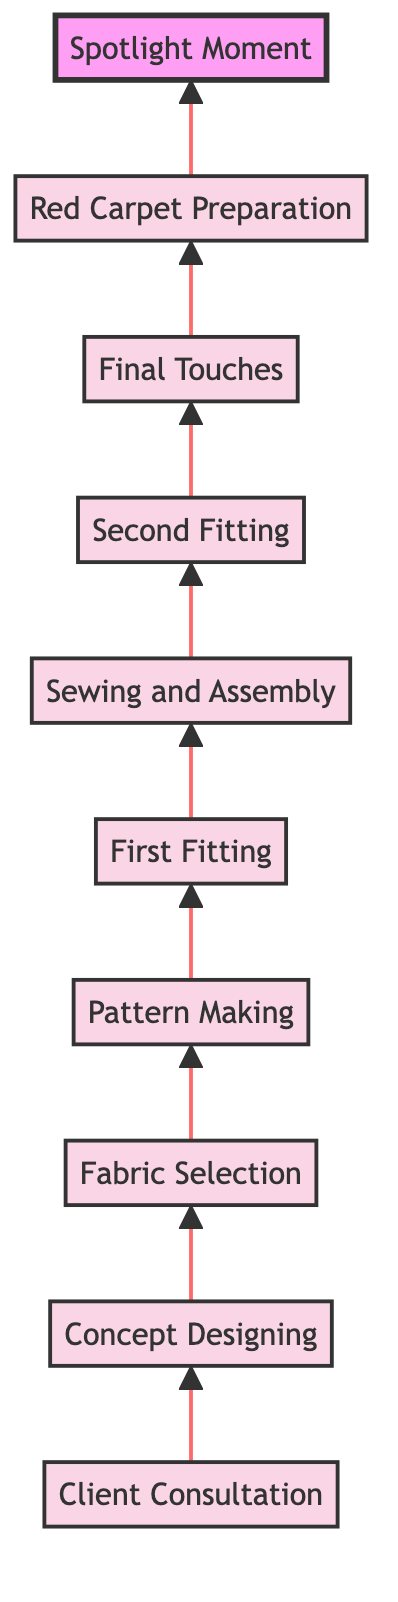What is the first step in the dress creation process? The first node at the bottom of the diagram is "Client Consultation," which indicates it is the starting point for the dress creation process.
Answer: Client Consultation How many total steps are there from the consultation to the spotlight moment? Counting all the nodes in the diagram from "Client Consultation" to "Spotlight Moment," there are ten steps total.
Answer: 10 What step comes immediately after "First Fitting"? The node that follows "First Fitting" is "Sewing and Assembly," indicating this is the next step in the process.
Answer: Sewing and Assembly Which step directly leads to the "Spotlight Moment"? The step that directly precedes "Spotlight Moment" is "Red Carpet Preparation," showing it's the final phase before the event.
Answer: Red Carpet Preparation What type of documents are created during "Concept Designing"? In "Concept Designing," initial sketches and mood boards are created that reflect the client's vision and design direction.
Answer: Sketches and mood boards How does the workflow progress after "Pattern Making"? After "Pattern Making," the workflow moves to "First Fitting," where the initial mockup is checked for adjustments.
Answer: First Fitting What is the last step in the dress creation timeline? The last node at the top of the diagram is "Spotlight Moment," which marks the culmination of the dress creation process.
Answer: Spotlight Moment Which step involves the client trying on a mockup of the dress? The "First Fitting" step specifically mentions creating a muslin mockup for the client to try on.
Answer: First Fitting Identify the stage that focuses on adding embellishments. The stage dedicated to adding details such as embroidery and sequins is "Sewing and Assembly."
Answer: Sewing and Assembly What is the flow direction of this diagram? The diagram flows from bottom to top, indicating a progression through stages of dress creation.
Answer: Bottom to top 